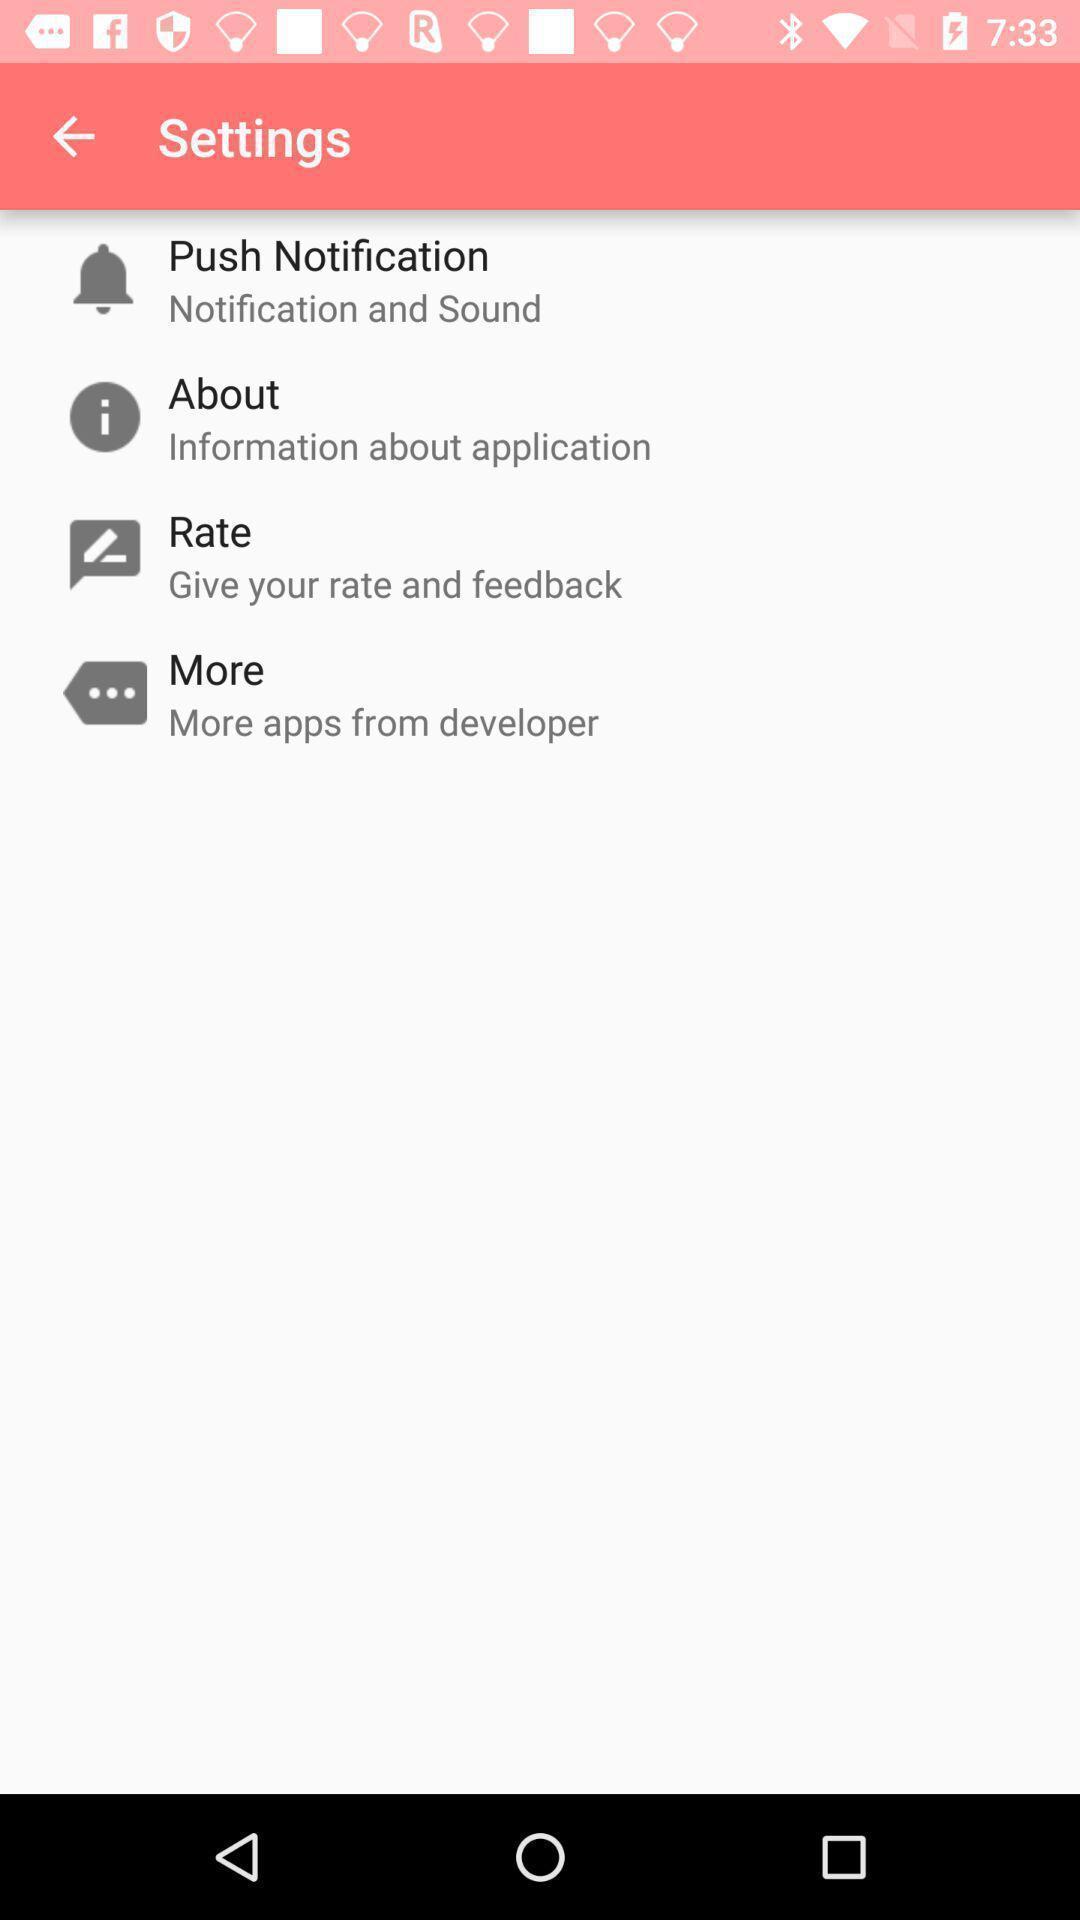What details can you identify in this image? Settings page in an emoji app. 